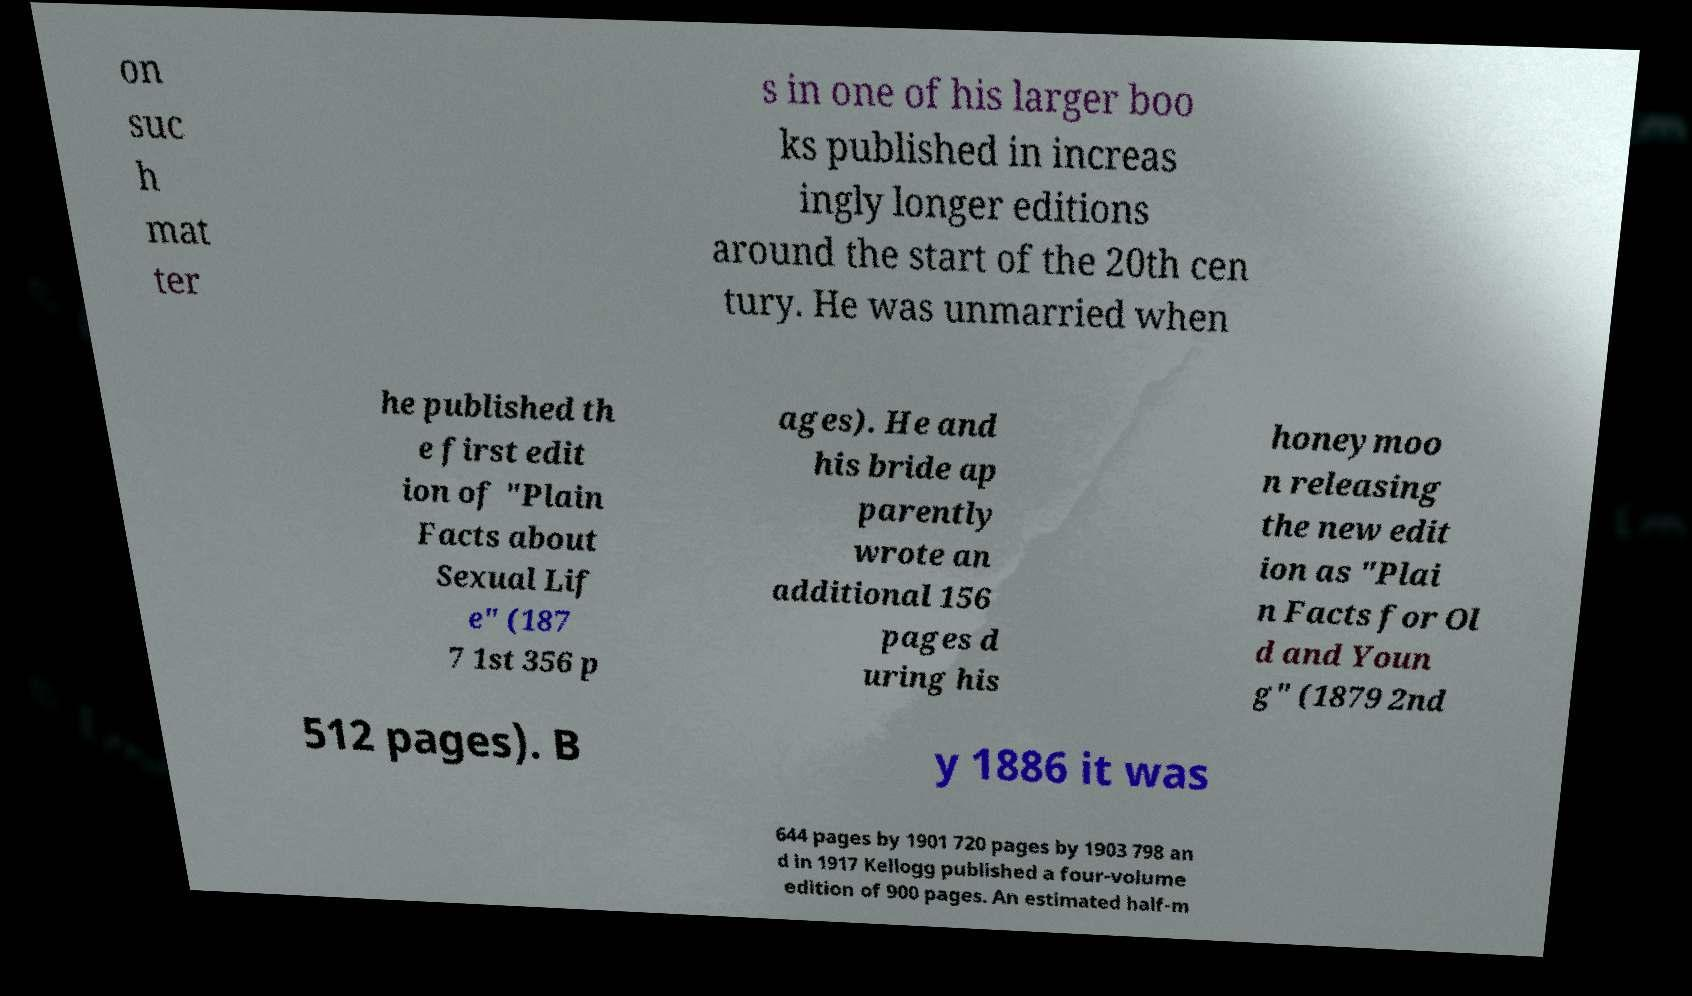There's text embedded in this image that I need extracted. Can you transcribe it verbatim? on suc h mat ter s in one of his larger boo ks published in increas ingly longer editions around the start of the 20th cen tury. He was unmarried when he published th e first edit ion of "Plain Facts about Sexual Lif e" (187 7 1st 356 p ages). He and his bride ap parently wrote an additional 156 pages d uring his honeymoo n releasing the new edit ion as "Plai n Facts for Ol d and Youn g" (1879 2nd 512 pages). B y 1886 it was 644 pages by 1901 720 pages by 1903 798 an d in 1917 Kellogg published a four-volume edition of 900 pages. An estimated half-m 